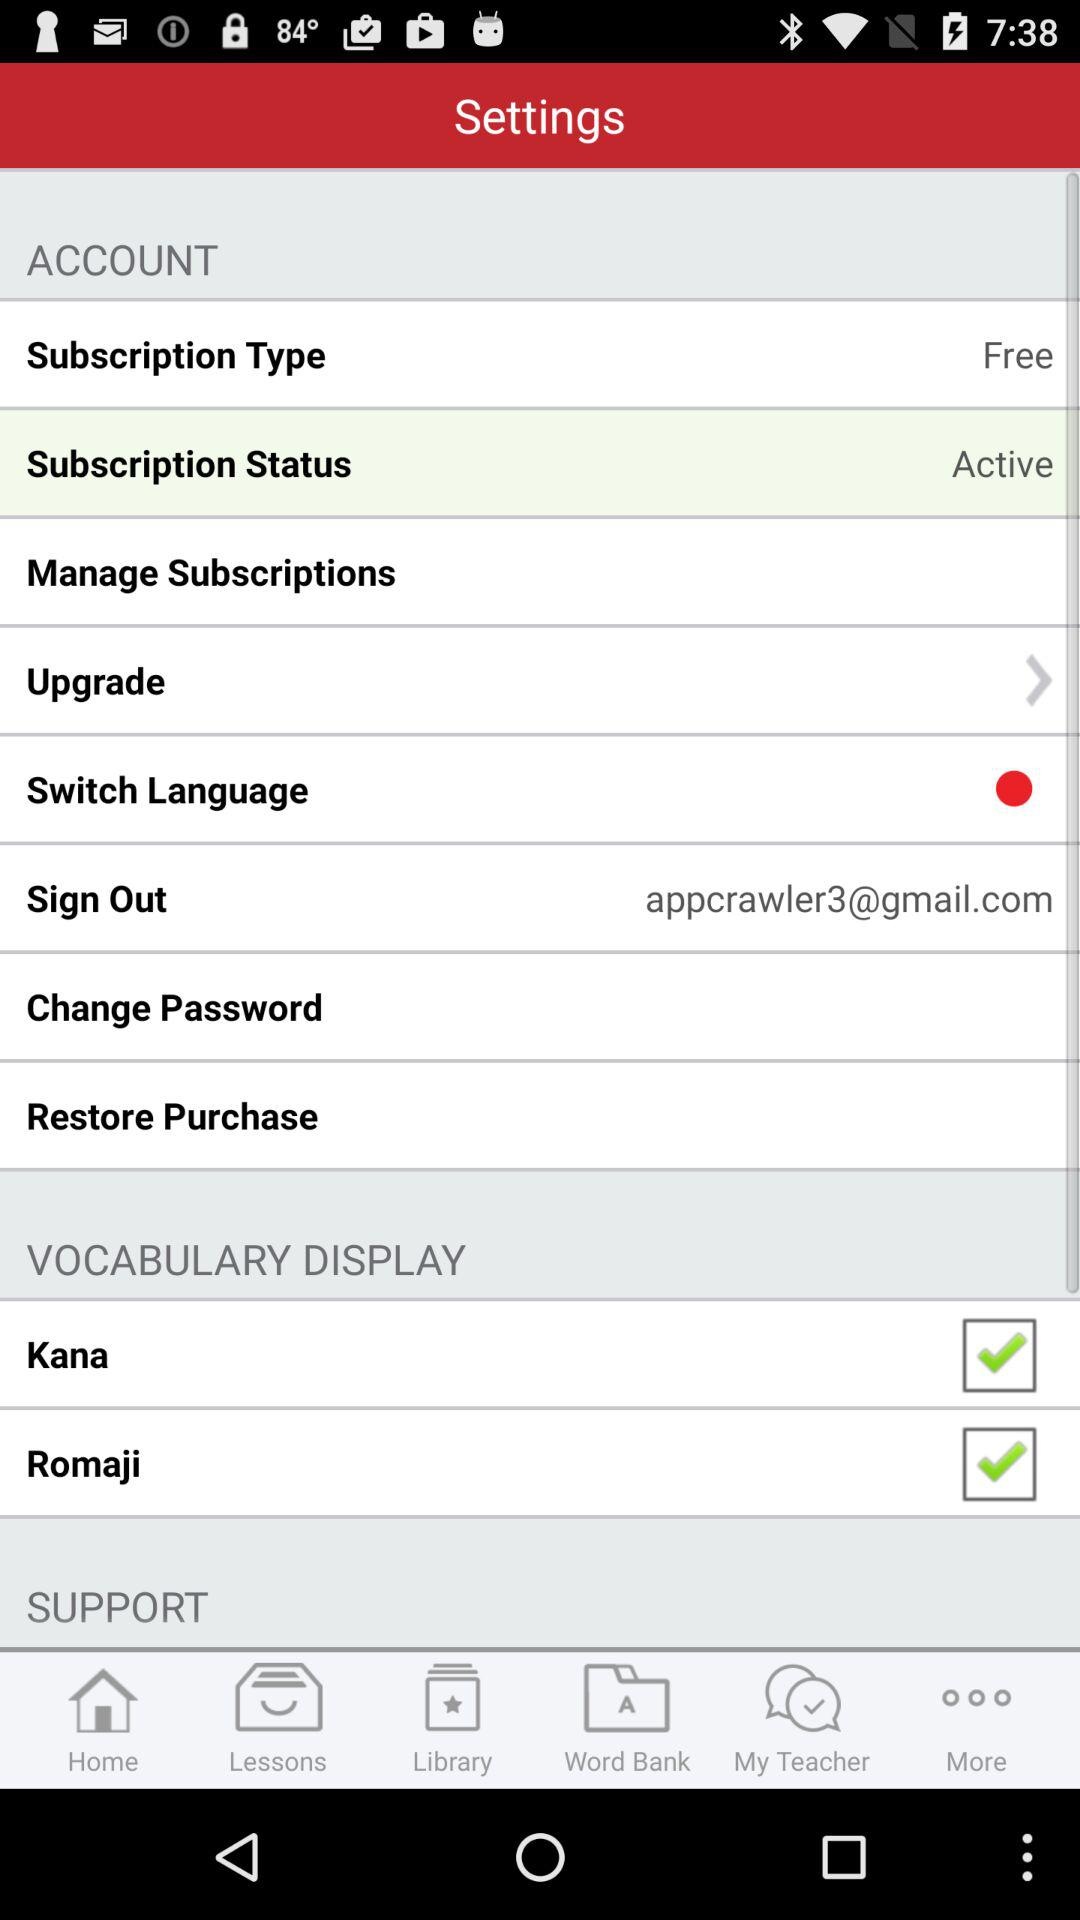What is the email address? The email address is appcrawler3@gmail.com. 